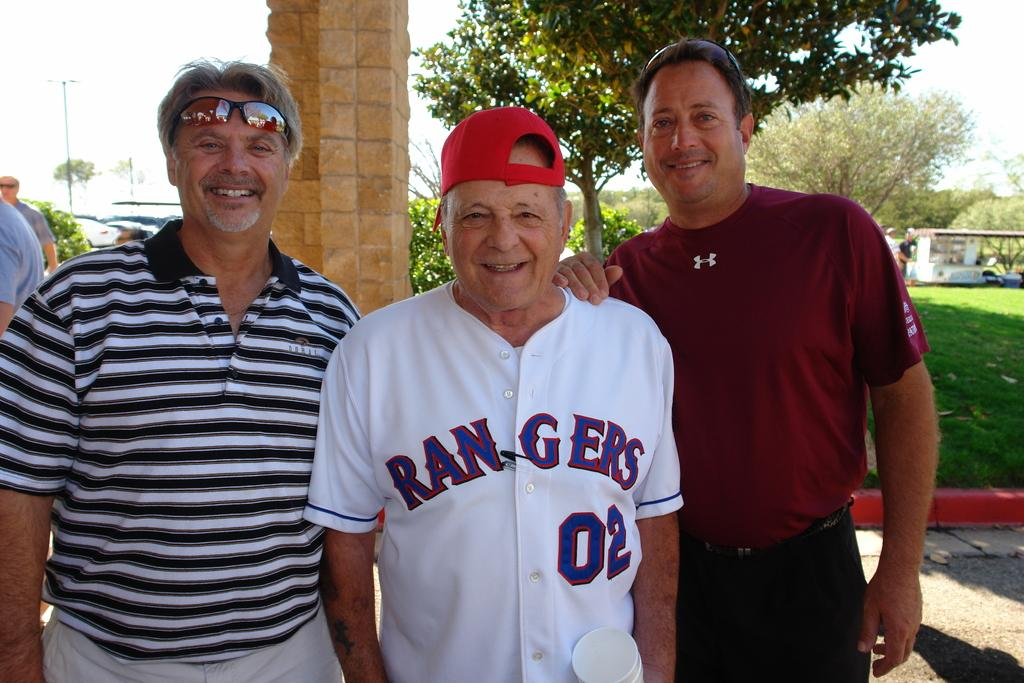<image>
Render a clear and concise summary of the photo. Two men pose with an elderly man in the middle wearing a Rangers baseball jersey. 